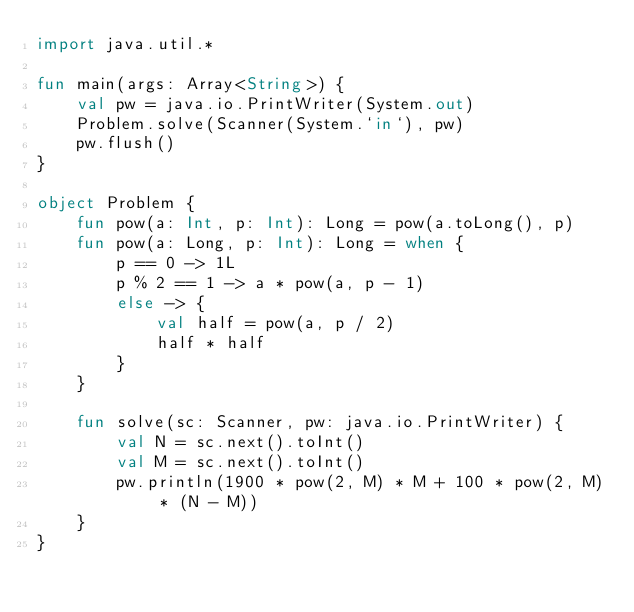<code> <loc_0><loc_0><loc_500><loc_500><_Kotlin_>import java.util.*

fun main(args: Array<String>) {
    val pw = java.io.PrintWriter(System.out)
    Problem.solve(Scanner(System.`in`), pw)
    pw.flush()
}

object Problem {
    fun pow(a: Int, p: Int): Long = pow(a.toLong(), p)
    fun pow(a: Long, p: Int): Long = when {
        p == 0 -> 1L
        p % 2 == 1 -> a * pow(a, p - 1)
        else -> {
            val half = pow(a, p / 2)
            half * half
        }
    }

    fun solve(sc: Scanner, pw: java.io.PrintWriter) {
        val N = sc.next().toInt()
        val M = sc.next().toInt()
        pw.println(1900 * pow(2, M) * M + 100 * pow(2, M) * (N - M))
    }
}
</code> 